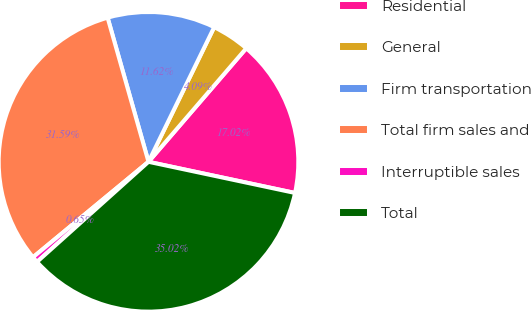<chart> <loc_0><loc_0><loc_500><loc_500><pie_chart><fcel>Residential<fcel>General<fcel>Firm transportation<fcel>Total firm sales and<fcel>Interruptible sales<fcel>Total<nl><fcel>17.02%<fcel>4.09%<fcel>11.62%<fcel>31.59%<fcel>0.65%<fcel>35.02%<nl></chart> 